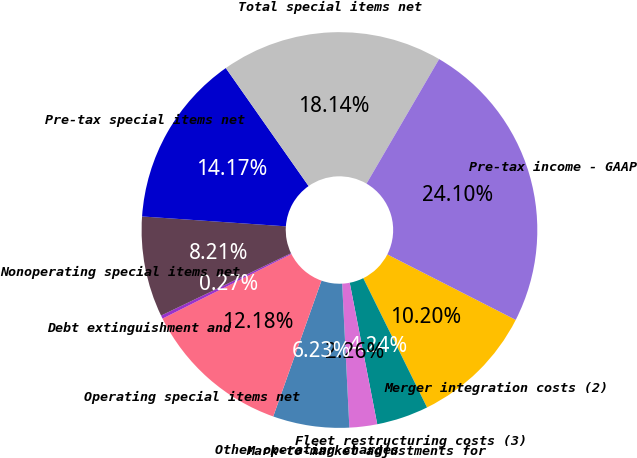<chart> <loc_0><loc_0><loc_500><loc_500><pie_chart><fcel>Merger integration costs (2)<fcel>Fleet restructuring costs (3)<fcel>Mark-to-market adjustments for<fcel>Other operating charges<fcel>Operating special items net<fcel>Debt extinguishment and<fcel>Nonoperating special items net<fcel>Pre-tax special items net<fcel>Total special items net<fcel>Pre-tax income - GAAP<nl><fcel>10.2%<fcel>4.24%<fcel>2.26%<fcel>6.23%<fcel>12.18%<fcel>0.27%<fcel>8.21%<fcel>14.17%<fcel>18.14%<fcel>24.1%<nl></chart> 